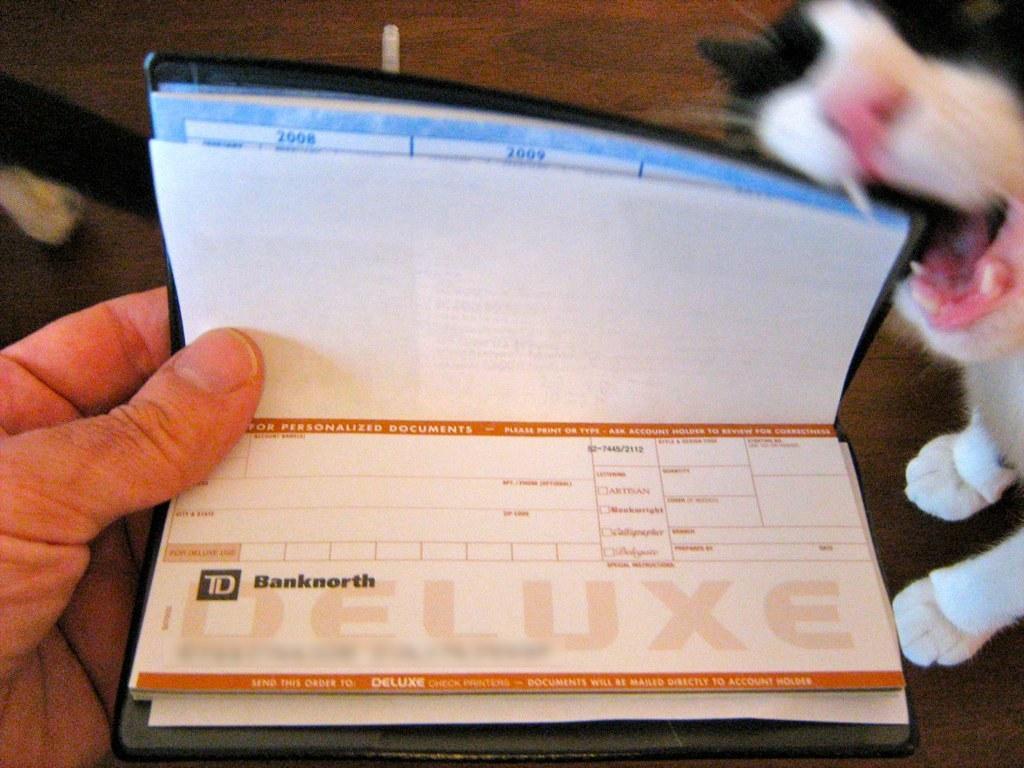How would you summarize this image in a sentence or two? In this image, I can see a person's hand holding a book. This looks like a cat. In the background, I can see the floor. 